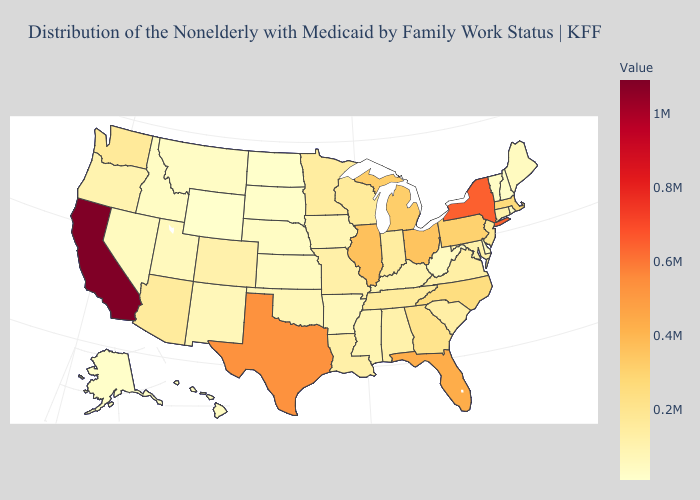Which states have the lowest value in the South?
Give a very brief answer. Delaware. Which states have the lowest value in the Northeast?
Answer briefly. New Hampshire. Which states have the lowest value in the West?
Be succinct. Wyoming. Does Wisconsin have the highest value in the USA?
Write a very short answer. No. Does New Mexico have the lowest value in the West?
Concise answer only. No. 